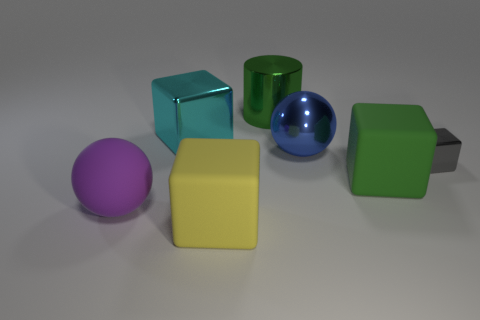Subtract all gray cubes. How many cubes are left? 3 Subtract all big metallic blocks. How many blocks are left? 3 Add 2 large red rubber cylinders. How many objects exist? 9 Subtract all blue blocks. Subtract all brown spheres. How many blocks are left? 4 Subtract all cubes. How many objects are left? 3 Add 1 cyan blocks. How many cyan blocks exist? 2 Subtract 0 brown balls. How many objects are left? 7 Subtract all cylinders. Subtract all gray metal objects. How many objects are left? 5 Add 4 gray shiny objects. How many gray shiny objects are left? 5 